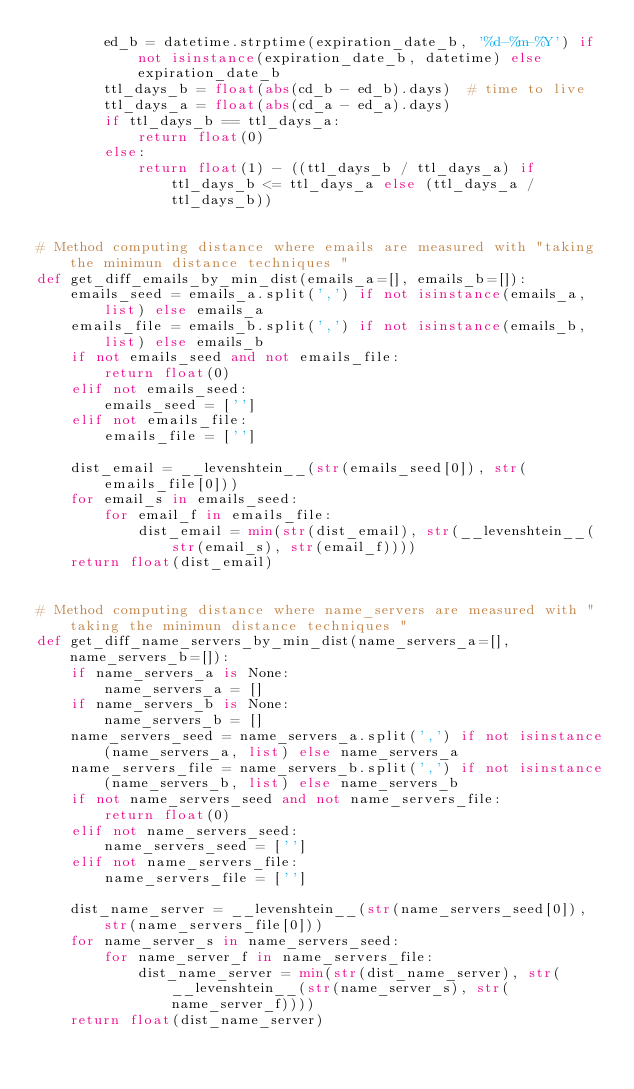<code> <loc_0><loc_0><loc_500><loc_500><_Python_>        ed_b = datetime.strptime(expiration_date_b, '%d-%m-%Y') if not isinstance(expiration_date_b, datetime) else expiration_date_b
        ttl_days_b = float(abs(cd_b - ed_b).days)  # time to live
        ttl_days_a = float(abs(cd_a - ed_a).days)
        if ttl_days_b == ttl_days_a:
            return float(0)
        else:
            return float(1) - ((ttl_days_b / ttl_days_a) if ttl_days_b <= ttl_days_a else (ttl_days_a / ttl_days_b))


# Method computing distance where emails are measured with "taking the minimun distance techniques "
def get_diff_emails_by_min_dist(emails_a=[], emails_b=[]):
    emails_seed = emails_a.split(',') if not isinstance(emails_a, list) else emails_a
    emails_file = emails_b.split(',') if not isinstance(emails_b, list) else emails_b
    if not emails_seed and not emails_file:
        return float(0)
    elif not emails_seed:
        emails_seed = ['']
    elif not emails_file:
        emails_file = ['']

    dist_email = __levenshtein__(str(emails_seed[0]), str(emails_file[0]))
    for email_s in emails_seed:
        for email_f in emails_file:
            dist_email = min(str(dist_email), str(__levenshtein__(str(email_s), str(email_f))))
    return float(dist_email)


# Method computing distance where name_servers are measured with "taking the minimun distance techniques "
def get_diff_name_servers_by_min_dist(name_servers_a=[], name_servers_b=[]):
    if name_servers_a is None:
        name_servers_a = []
    if name_servers_b is None:
        name_servers_b = []
    name_servers_seed = name_servers_a.split(',') if not isinstance(name_servers_a, list) else name_servers_a
    name_servers_file = name_servers_b.split(',') if not isinstance(name_servers_b, list) else name_servers_b
    if not name_servers_seed and not name_servers_file:
        return float(0)
    elif not name_servers_seed:
        name_servers_seed = ['']
    elif not name_servers_file:
        name_servers_file = ['']

    dist_name_server = __levenshtein__(str(name_servers_seed[0]), str(name_servers_file[0]))
    for name_server_s in name_servers_seed:
        for name_server_f in name_servers_file:
            dist_name_server = min(str(dist_name_server), str(__levenshtein__(str(name_server_s), str(name_server_f))))
    return float(dist_name_server)

</code> 